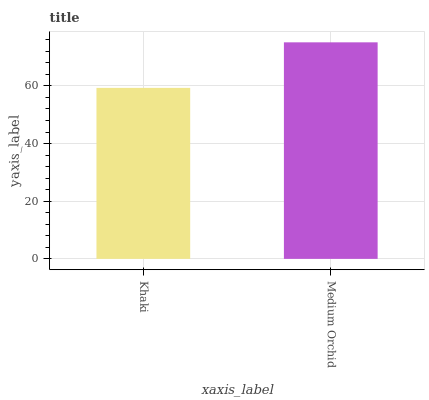Is Khaki the minimum?
Answer yes or no. Yes. Is Medium Orchid the maximum?
Answer yes or no. Yes. Is Medium Orchid the minimum?
Answer yes or no. No. Is Medium Orchid greater than Khaki?
Answer yes or no. Yes. Is Khaki less than Medium Orchid?
Answer yes or no. Yes. Is Khaki greater than Medium Orchid?
Answer yes or no. No. Is Medium Orchid less than Khaki?
Answer yes or no. No. Is Medium Orchid the high median?
Answer yes or no. Yes. Is Khaki the low median?
Answer yes or no. Yes. Is Khaki the high median?
Answer yes or no. No. Is Medium Orchid the low median?
Answer yes or no. No. 